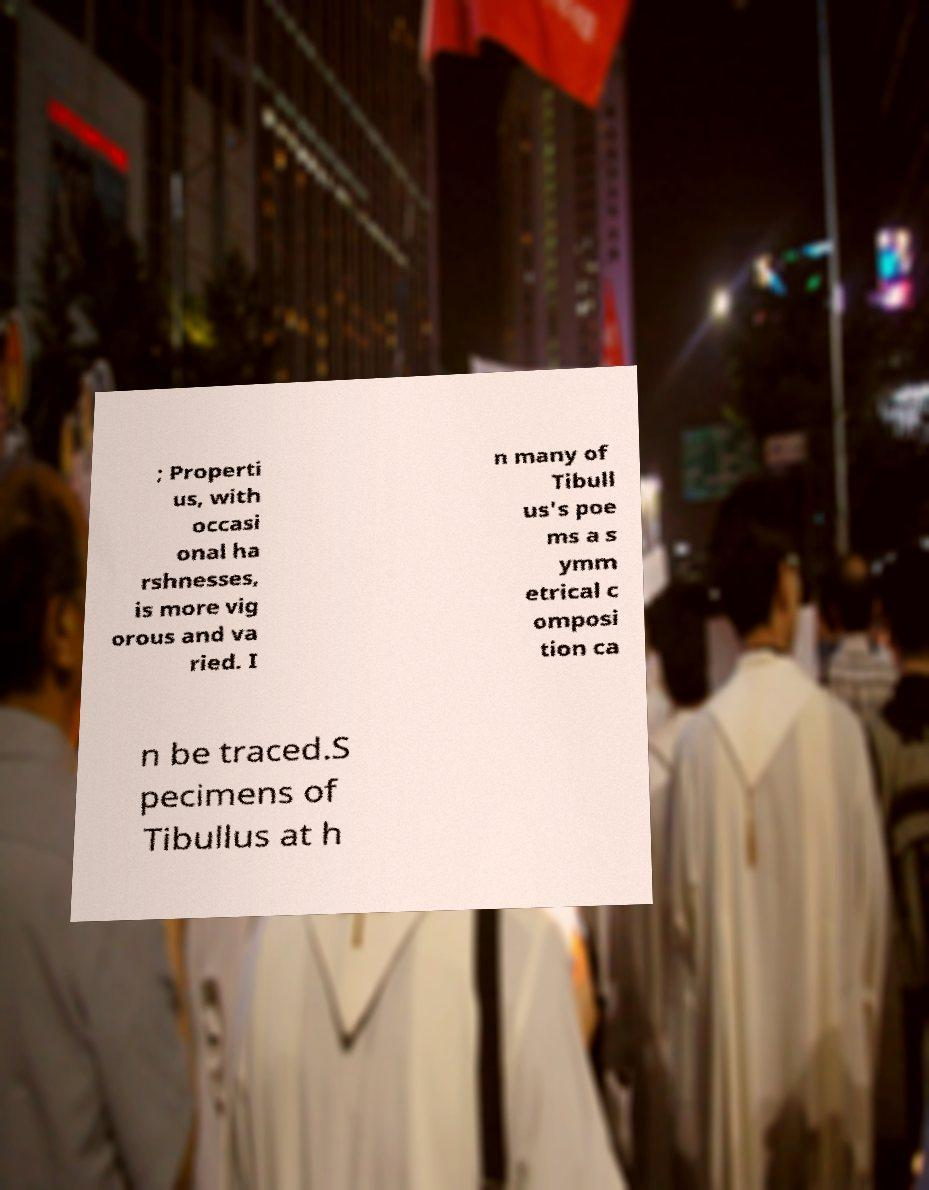Please read and relay the text visible in this image. What does it say? ; Properti us, with occasi onal ha rshnesses, is more vig orous and va ried. I n many of Tibull us's poe ms a s ymm etrical c omposi tion ca n be traced.S pecimens of Tibullus at h 